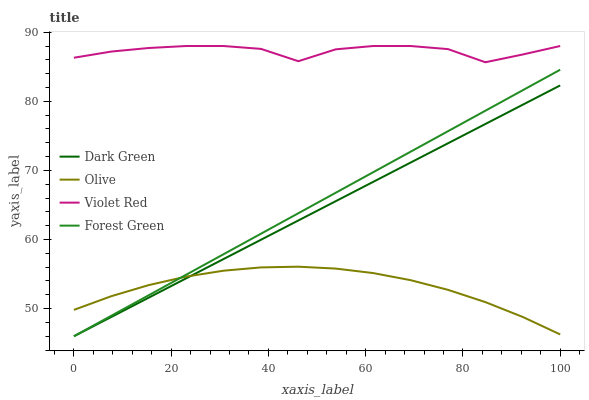Does Forest Green have the minimum area under the curve?
Answer yes or no. No. Does Forest Green have the maximum area under the curve?
Answer yes or no. No. Is Forest Green the smoothest?
Answer yes or no. No. Is Forest Green the roughest?
Answer yes or no. No. Does Violet Red have the lowest value?
Answer yes or no. No. Does Forest Green have the highest value?
Answer yes or no. No. Is Forest Green less than Violet Red?
Answer yes or no. Yes. Is Violet Red greater than Forest Green?
Answer yes or no. Yes. Does Forest Green intersect Violet Red?
Answer yes or no. No. 